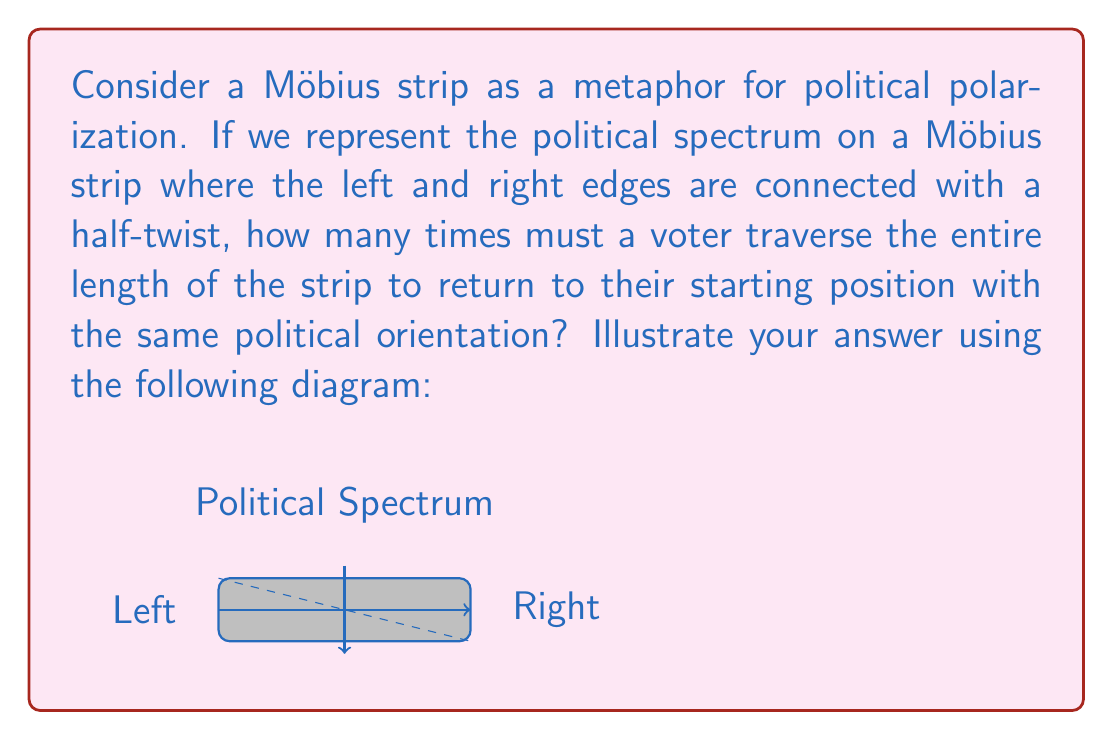Solve this math problem. To solve this problem, we need to understand the properties of a Möbius strip:

1) A Möbius strip is a non-orientable surface with only one side and one edge.

2) It is created by taking a strip of paper, giving it a half-twist, and then joining the ends.

3) In our political metaphor, the left and right extremes are connected, but with a twist.

Now, let's analyze the traversal:

1) Starting at any point, when we traverse the length of the strip once, we end up on the "opposite" side of our starting point.

2) This means that after one traversal, a voter who started on the "top" of the strip would find themselves on the "bottom", effectively flipping their political orientation.

3) To return to the original position and orientation, the voter needs to traverse the strip again.

4) After the second traversal, the voter will be back at the starting point with the same orientation.

Mathematically, this can be represented as:

$$\text{Number of traversals} = 2$$

This property of the Möbius strip illustrates how in a polarized political landscape, extreme views on opposite ends of the spectrum can sometimes lead to similar outcomes, and how a complete understanding of the political landscape requires multiple perspectives.
Answer: 2 traversals 